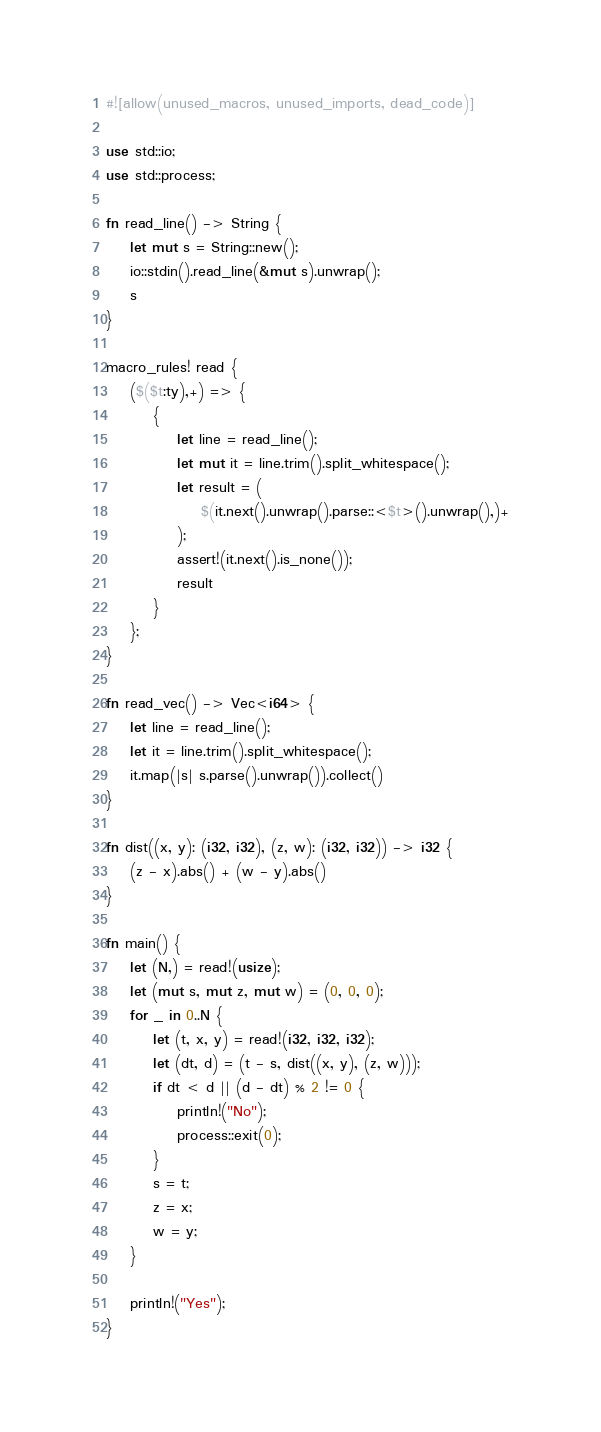Convert code to text. <code><loc_0><loc_0><loc_500><loc_500><_Rust_>#![allow(unused_macros, unused_imports, dead_code)]

use std::io;
use std::process;

fn read_line() -> String {
    let mut s = String::new();
    io::stdin().read_line(&mut s).unwrap();
    s
}

macro_rules! read {
    ($($t:ty),+) => {
        {
            let line = read_line();
            let mut it = line.trim().split_whitespace();
            let result = (
                $(it.next().unwrap().parse::<$t>().unwrap(),)+
            );
            assert!(it.next().is_none());
            result
        }
    };
}

fn read_vec() -> Vec<i64> {
    let line = read_line();
    let it = line.trim().split_whitespace();
    it.map(|s| s.parse().unwrap()).collect()
}

fn dist((x, y): (i32, i32), (z, w): (i32, i32)) -> i32 {
    (z - x).abs() + (w - y).abs()
}

fn main() {
    let (N,) = read!(usize);
    let (mut s, mut z, mut w) = (0, 0, 0);
    for _ in 0..N {
        let (t, x, y) = read!(i32, i32, i32);
        let (dt, d) = (t - s, dist((x, y), (z, w)));
        if dt < d || (d - dt) % 2 != 0 {
            println!("No");
            process::exit(0);
        }
        s = t;
        z = x;
        w = y;
    }

    println!("Yes");    
}</code> 